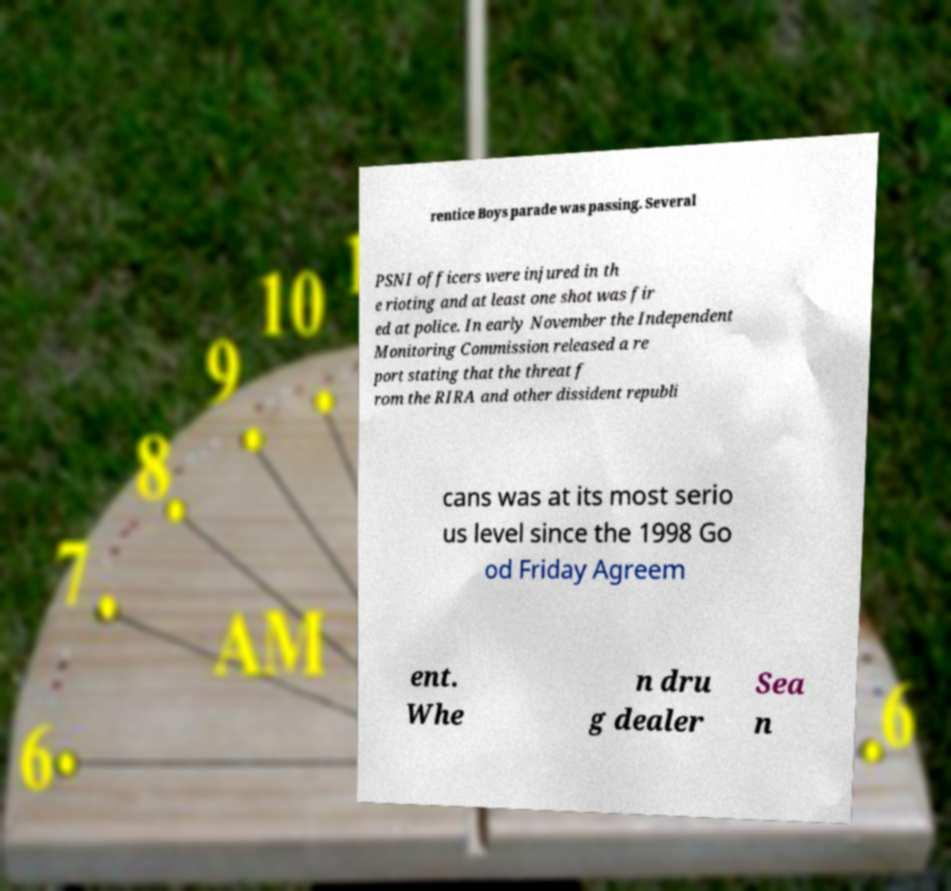I need the written content from this picture converted into text. Can you do that? rentice Boys parade was passing. Several PSNI officers were injured in th e rioting and at least one shot was fir ed at police. In early November the Independent Monitoring Commission released a re port stating that the threat f rom the RIRA and other dissident republi cans was at its most serio us level since the 1998 Go od Friday Agreem ent. Whe n dru g dealer Sea n 